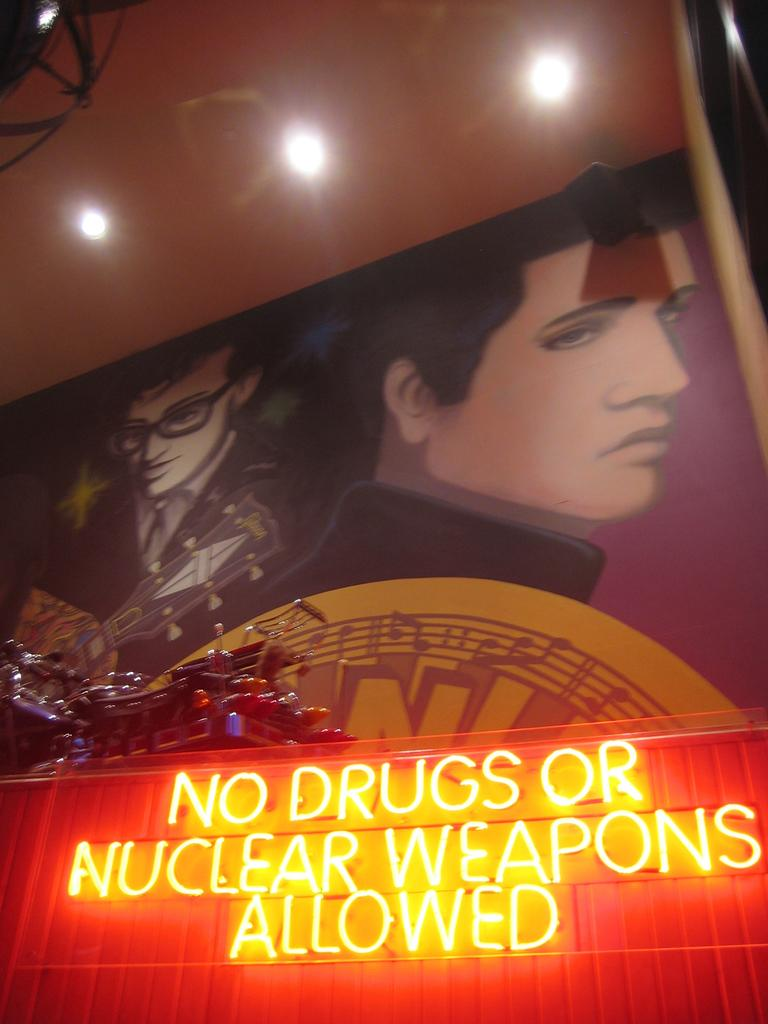<image>
Offer a succinct explanation of the picture presented. Art with a sign below it that read no drugs or nuclear weapons allowed. 